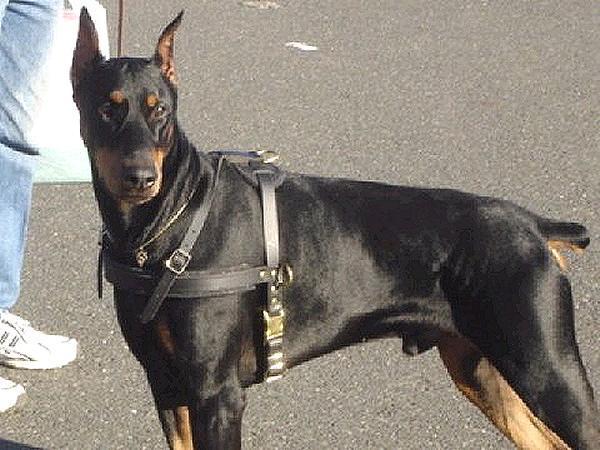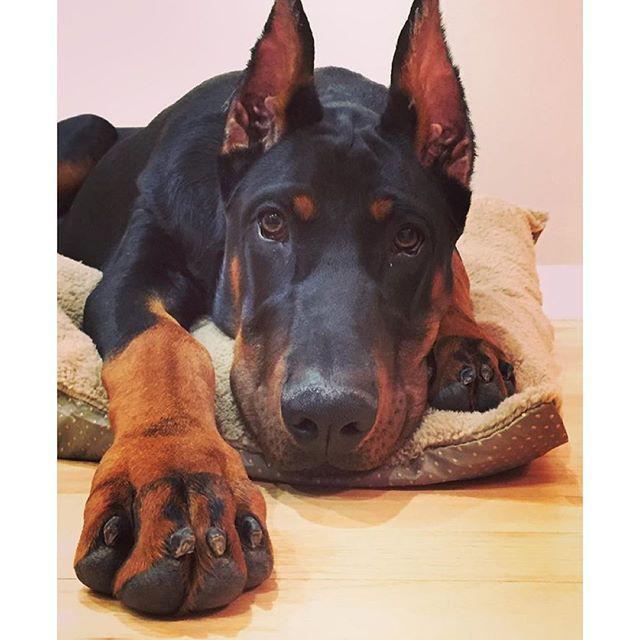The first image is the image on the left, the second image is the image on the right. For the images displayed, is the sentence "The left and right image contains the same number of dogs, one being a puppy and the other being an adult." factually correct? Answer yes or no. No. The first image is the image on the left, the second image is the image on the right. Considering the images on both sides, is "The left image contains one adult doberman with erect ears and its face straight ahead, and the right image includes at least one doberman reclining on something soft." valid? Answer yes or no. Yes. 